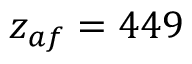<formula> <loc_0><loc_0><loc_500><loc_500>z _ { a f } = 4 4 9</formula> 